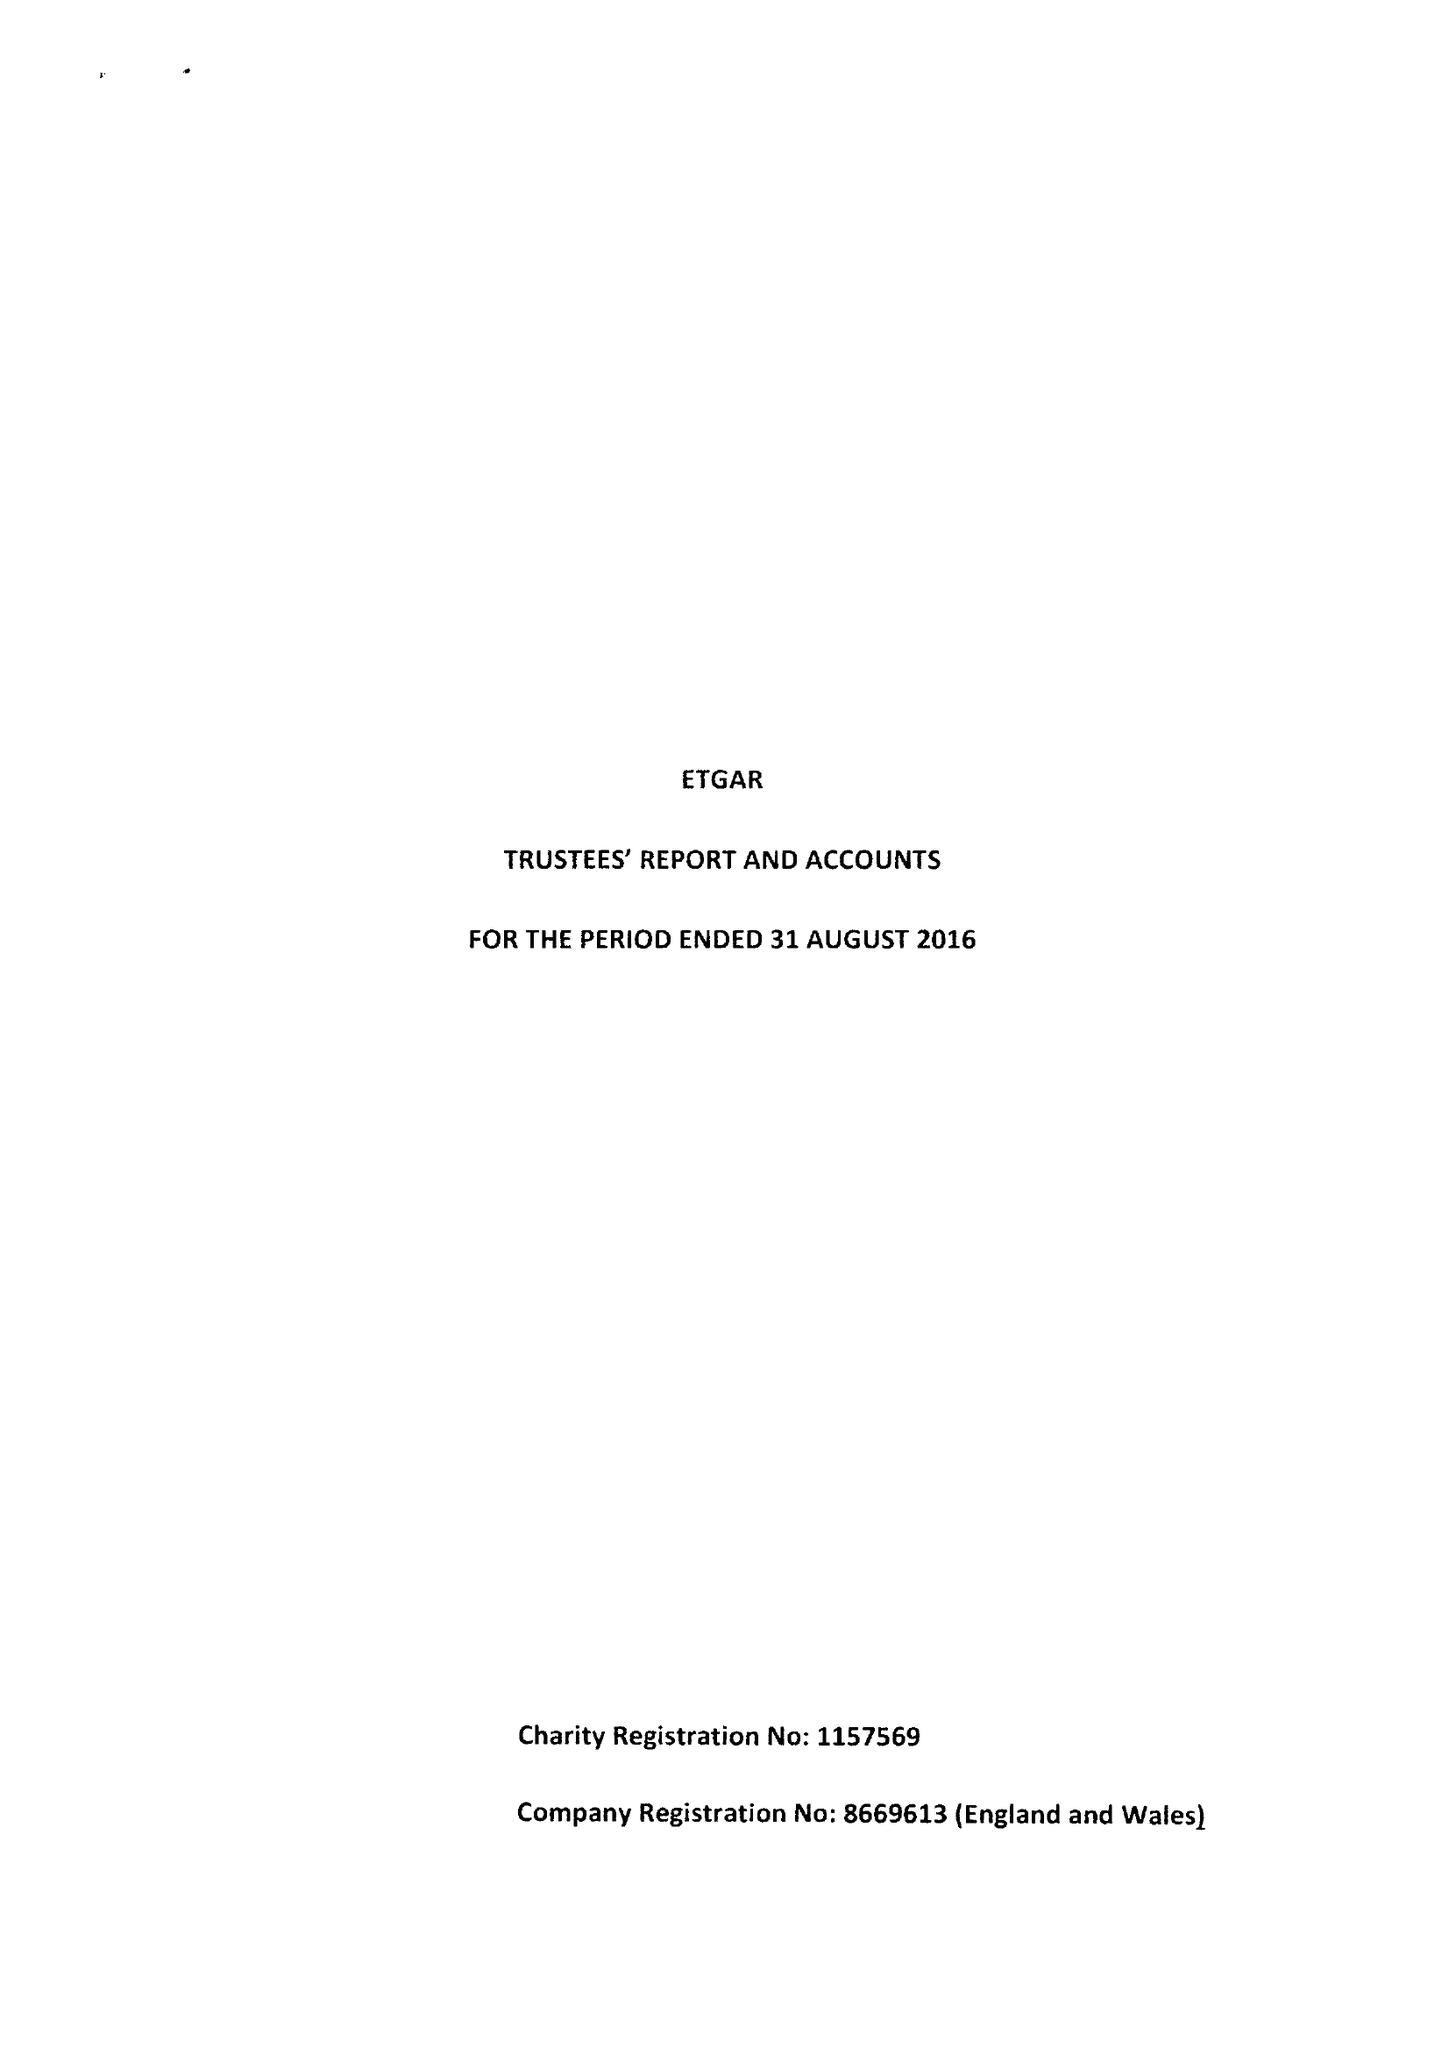What is the value for the charity_number?
Answer the question using a single word or phrase. 1157569 